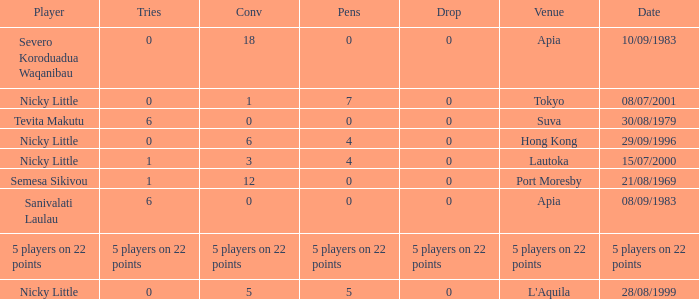How many drops did Nicky Little have in Hong Kong? 0.0. 